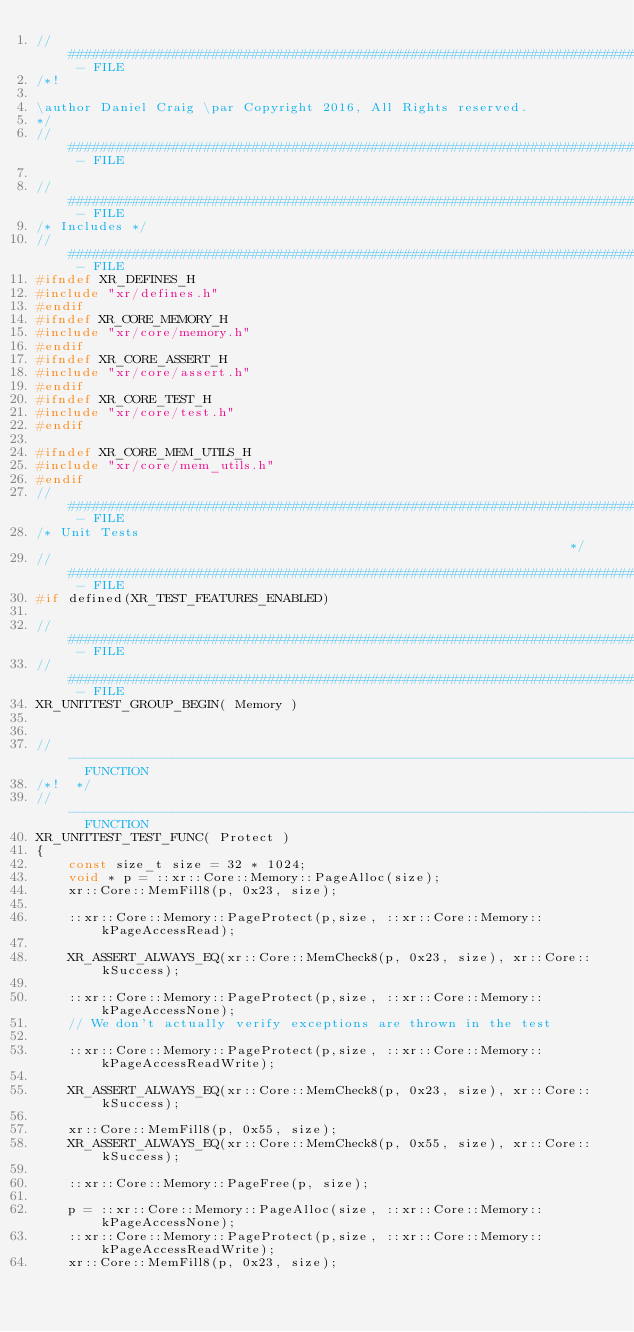<code> <loc_0><loc_0><loc_500><loc_500><_C++_>// ######################################################################################### - FILE
/*!

\author Daniel Craig \par Copyright 2016, All Rights reserved.
*/
// ######################################################################################### - FILE

// ######################################################################################### - FILE
/* Includes */
// ######################################################################################### - FILE
#ifndef XR_DEFINES_H
#include "xr/defines.h"
#endif
#ifndef XR_CORE_MEMORY_H
#include "xr/core/memory.h"
#endif
#ifndef XR_CORE_ASSERT_H
#include "xr/core/assert.h"
#endif
#ifndef XR_CORE_TEST_H
#include "xr/core/test.h"
#endif

#ifndef XR_CORE_MEM_UTILS_H
#include "xr/core/mem_utils.h"
#endif
// ######################################################################################### - FILE
/* Unit Tests                                                                */
// ######################################################################################### - FILE
#if defined(XR_TEST_FEATURES_ENABLED)

// ######################################################################################### - FILE
// ######################################################################################### - FILE
XR_UNITTEST_GROUP_BEGIN( Memory )


// --------------------------------------------------------------------------------------  FUNCTION
/*!  */
// --------------------------------------------------------------------------------------  FUNCTION
XR_UNITTEST_TEST_FUNC( Protect )
{
    const size_t size = 32 * 1024;
    void * p = ::xr::Core::Memory::PageAlloc(size);
    xr::Core::MemFill8(p, 0x23, size);

    ::xr::Core::Memory::PageProtect(p,size, ::xr::Core::Memory::kPageAccessRead);

    XR_ASSERT_ALWAYS_EQ(xr::Core::MemCheck8(p, 0x23, size), xr::Core::kSuccess);

    ::xr::Core::Memory::PageProtect(p,size, ::xr::Core::Memory::kPageAccessNone);
    // We don't actually verify exceptions are thrown in the test

    ::xr::Core::Memory::PageProtect(p,size, ::xr::Core::Memory::kPageAccessReadWrite);

    XR_ASSERT_ALWAYS_EQ(xr::Core::MemCheck8(p, 0x23, size), xr::Core::kSuccess);

    xr::Core::MemFill8(p, 0x55, size);
    XR_ASSERT_ALWAYS_EQ(xr::Core::MemCheck8(p, 0x55, size), xr::Core::kSuccess);

    ::xr::Core::Memory::PageFree(p, size);

    p = ::xr::Core::Memory::PageAlloc(size, ::xr::Core::Memory::kPageAccessNone);
    ::xr::Core::Memory::PageProtect(p,size, ::xr::Core::Memory::kPageAccessReadWrite);
    xr::Core::MemFill8(p, 0x23, size);</code> 